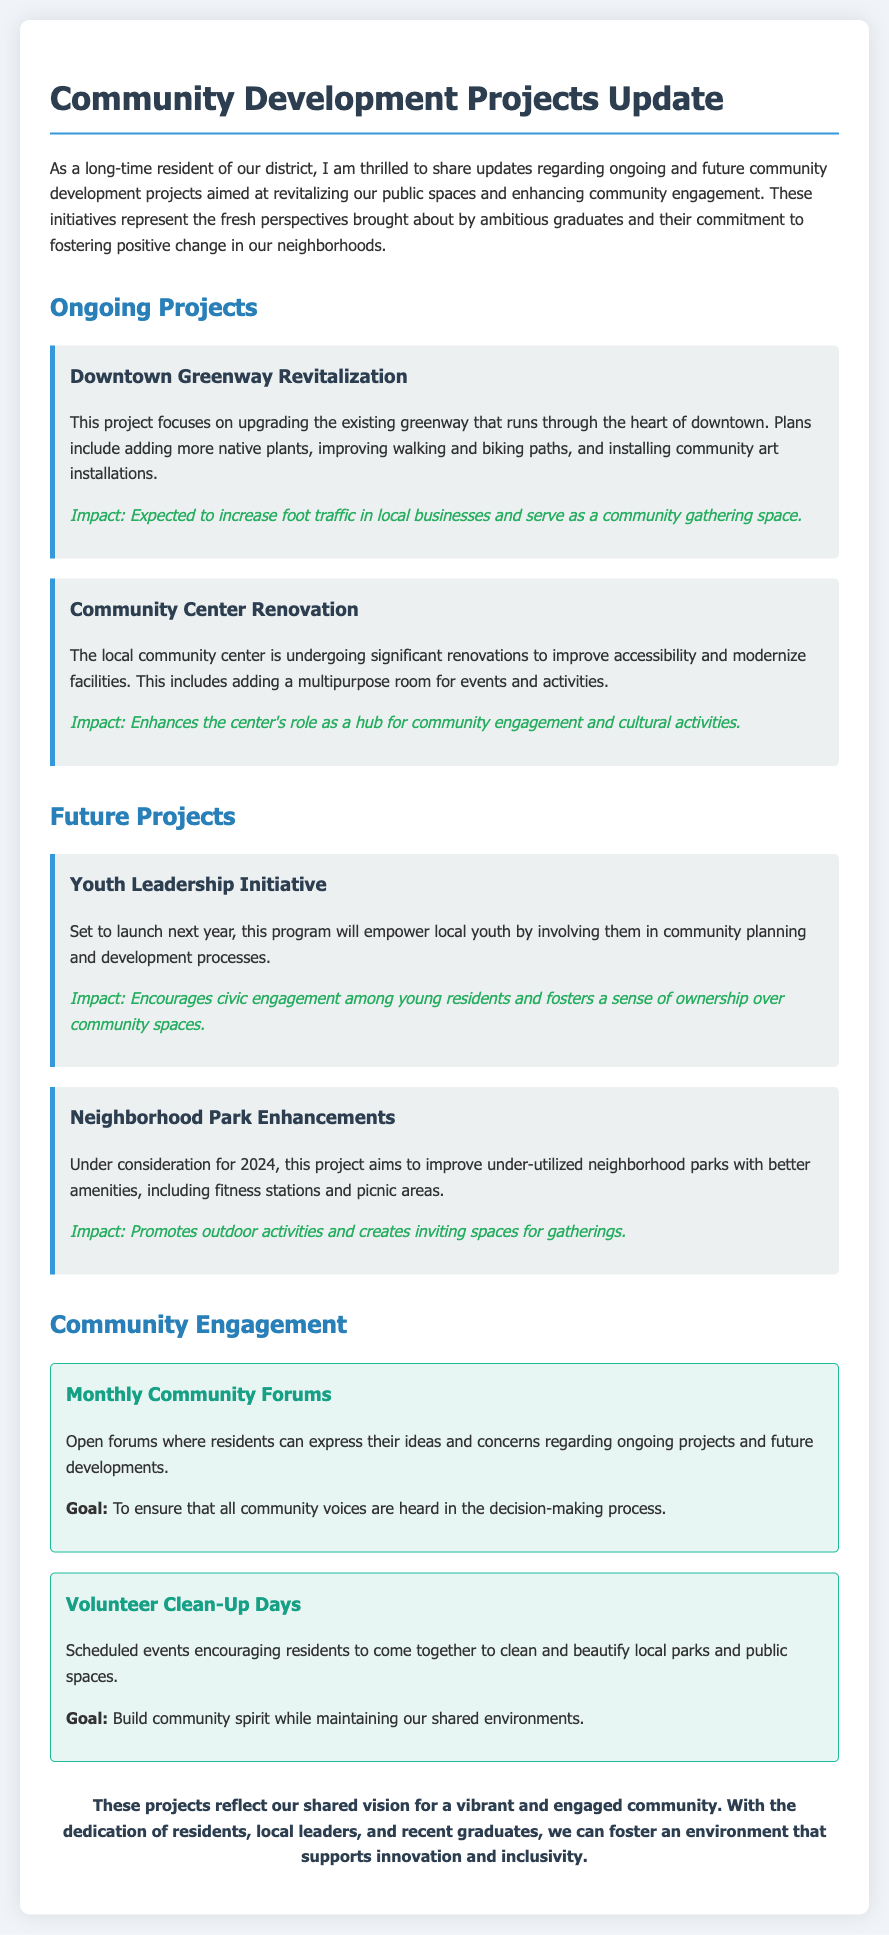What is the title of the document? The title of the document is found at the top of the memo.
Answer: Community Development Projects Update What project focuses on upgrading the greenway in downtown? The specific project that targets the downtown greenway is highlighted in the ongoing projects section.
Answer: Downtown Greenway Revitalization What is a major feature of the Community Center Renovation? This information is mentioned in relation to improvements being made to the local community center.
Answer: Multipurpose room When will the Youth Leadership Initiative launch? The memo specifies when the initiative is set to begin.
Answer: Next year What enhancement is under consideration for 2024? The future projects section includes details about this specific consideration.
Answer: Neighborhood Park Enhancements What is the goal of the Monthly Community Forums? The memo explains the objective of these forums in the community engagement section.
Answer: Ensure that all community voices are heard How do the Volunteer Clean-Up Days help the community? This information discusses the impact of these events on the community spirit.
Answer: Build community spirit What type of spaces will be improved in under-utilized neighborhood parks? The project aims to enhance specific amenities within these parks.
Answer: Fitness stations and picnic areas 